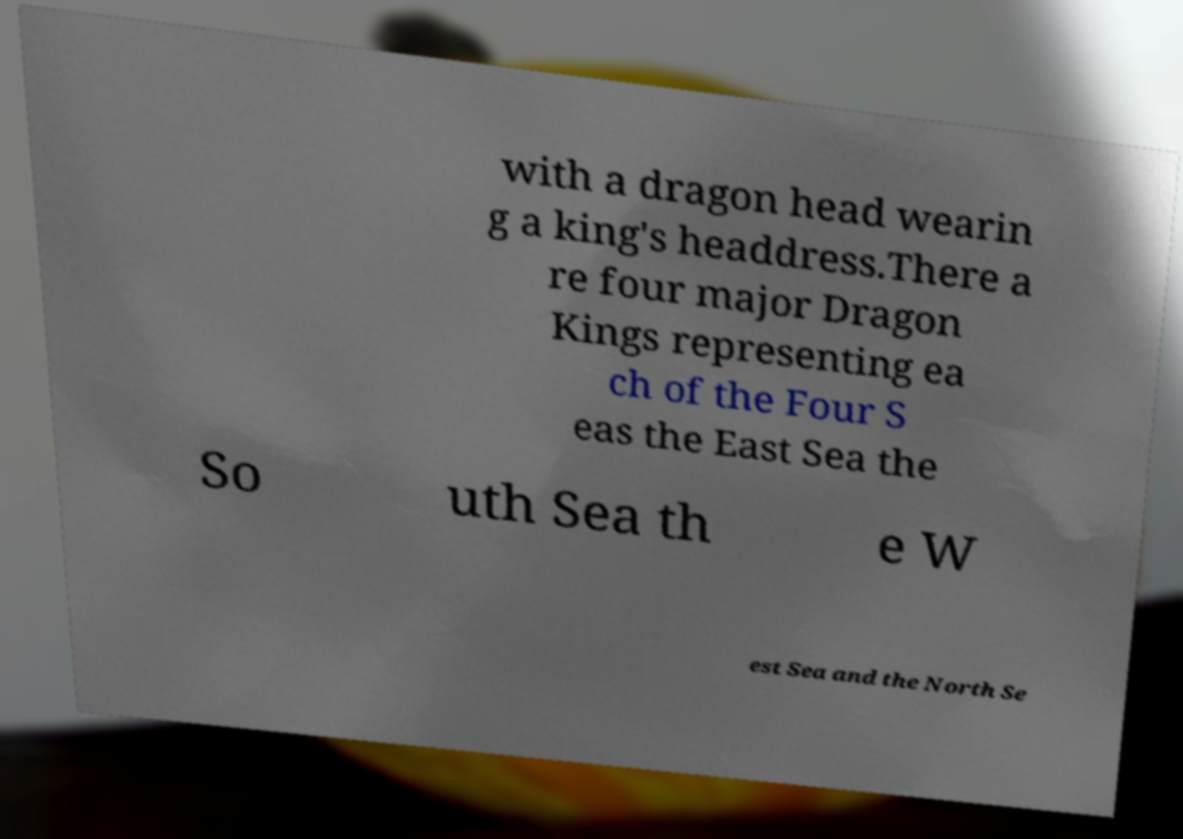Could you extract and type out the text from this image? with a dragon head wearin g a king's headdress.There a re four major Dragon Kings representing ea ch of the Four S eas the East Sea the So uth Sea th e W est Sea and the North Se 